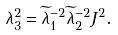Convert formula to latex. <formula><loc_0><loc_0><loc_500><loc_500>\lambda _ { 3 } ^ { 2 } = \widetilde { \lambda } ^ { - 2 } _ { 1 } \widetilde { \lambda } ^ { - 2 } _ { 2 } J ^ { 2 } .</formula> 